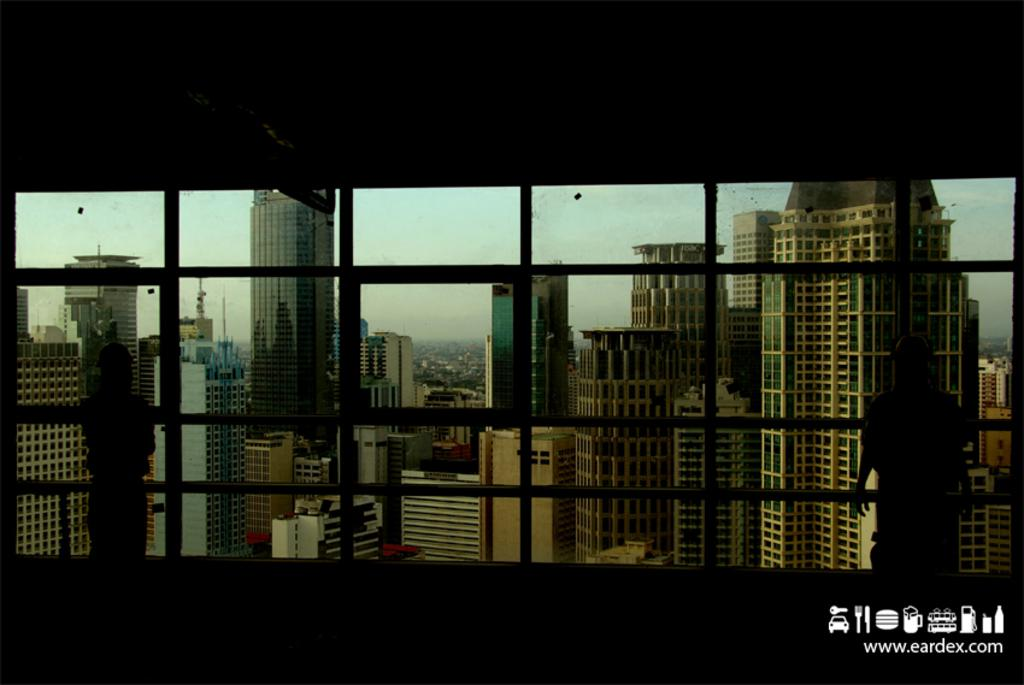What type of structures can be seen in the image? There are buildings in the image. What part of the natural environment is visible in the image? The sky is visible in the image. Can you describe the person in the image? There is a person standing on the right side of the image. How would you describe the lighting in the image? The image is a little dark. What type of record is being played on the needle in the image? There is no record or needle present in the image. How does the heat affect the buildings in the image? The image does not show any heat or its effects on the buildings; it only shows the buildings and the sky. 